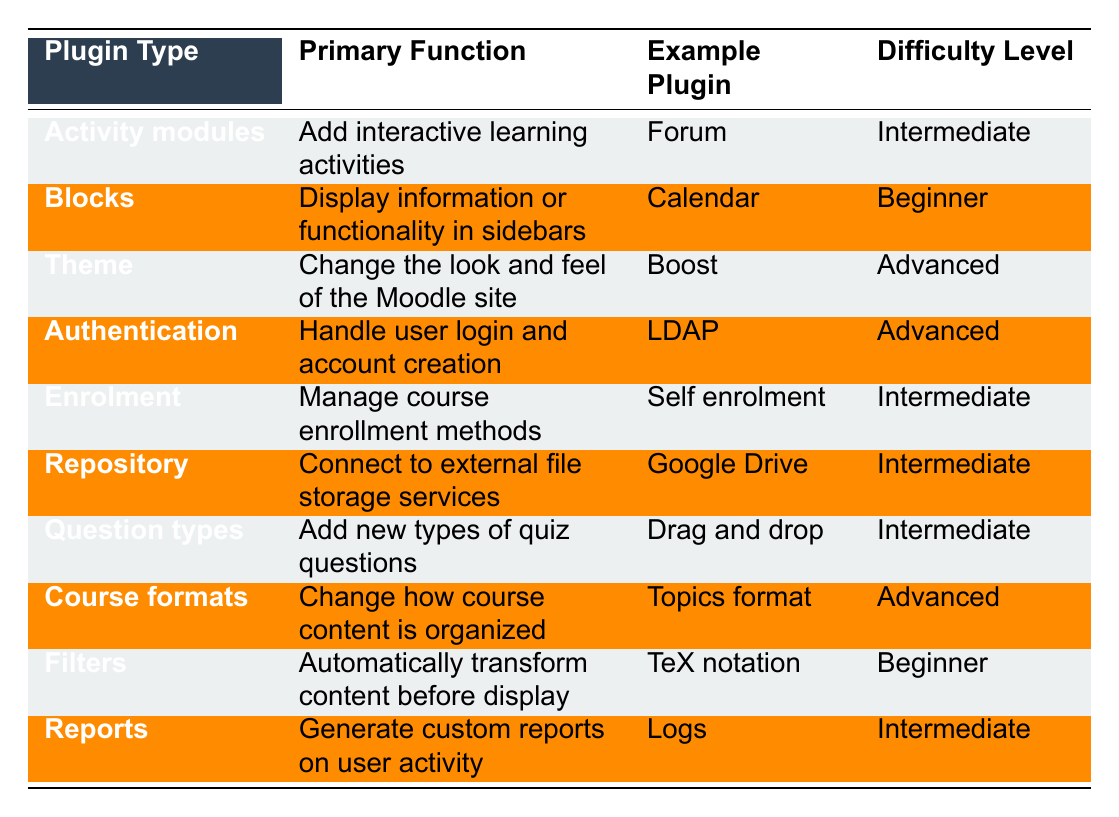What is the primary function of Blocks? According to the table, the primary function of Blocks is to display information or functionality in sidebars.
Answer: Display information or functionality in sidebars Which plugin type has the highest difficulty level? Scanning through the table, both Theme and Authentication are categorized as 'Advanced' difficulty level.
Answer: Theme and Authentication How many plugin types listed have a difficulty level of Intermediate? By counting the rows in the table with 'Intermediate,' we find there are five such entries: Activity modules, Enrolment, Repository, Question types, and Reports.
Answer: Five Does the Calendar plugin belong to the Activity modules category? The table indicates that the Calendar is an example plugin under the Blocks category, not Activity modules.
Answer: No What are the two plugin types that handle user login and account management functions? On the table, Authentication is the category for handling user login, while there isn't a second type listed that does this.
Answer: Authentication What is the example plugin for the Course formats type? The example plugin listed under Course formats is Topics format, as shown in the table.
Answer: Topics format Is there any plugin type with a primary function to automatically transform content? The table indicates there is a plugin type under Filters that automatically transforms content before display, which confirms the presence of such a function.
Answer: Yes Which plugin has a primary function of managing course enrollment methods? According to the table, the Enrolment plugin type is responsible for managing course enrollment methods.
Answer: Enrolment If you wanted to connect to Google Drive, which Moodle plugin type would you use? The table notes that Google Drive falls under the Repository plugin type, which connects to external file storage services.
Answer: Repository Which plugin type has the same difficulty level as the Forum? The Forum is an example of an Activity modules plugin, which is categorized as Intermediate; hence the plugin types Enrolment, Repository, Question types, and Reports also share this level.
Answer: Enrolment, Repository, Question types, Reports 